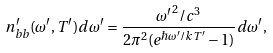Convert formula to latex. <formula><loc_0><loc_0><loc_500><loc_500>n ^ { \prime } _ { b b } ( \omega ^ { \prime } , T ^ { \prime } ) d \omega ^ { \prime } = \frac { { \omega ^ { \prime } } ^ { 2 } / c ^ { 3 } } { 2 \pi ^ { 2 } ( e ^ { \hbar { \omega } ^ { \prime } / k T ^ { \prime } } - 1 ) } d \omega ^ { \prime } ,</formula> 